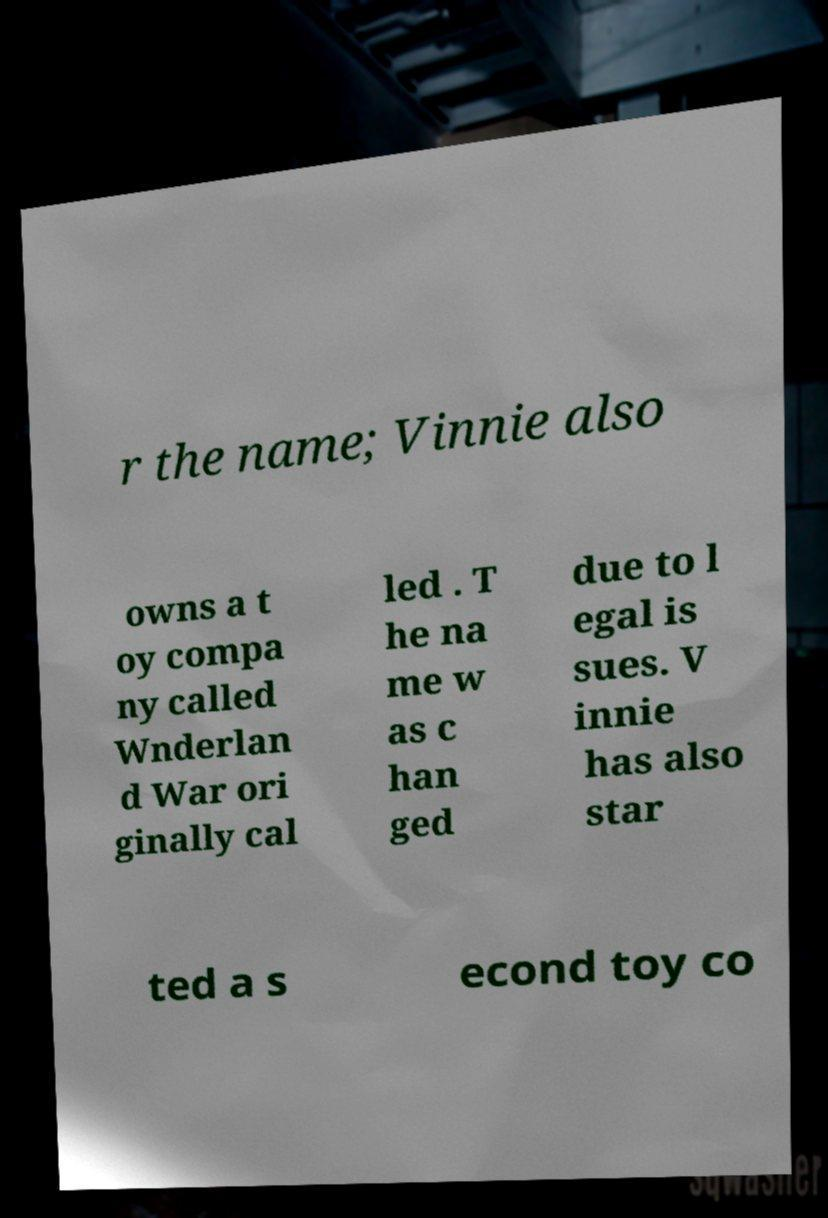Can you accurately transcribe the text from the provided image for me? r the name; Vinnie also owns a t oy compa ny called Wnderlan d War ori ginally cal led . T he na me w as c han ged due to l egal is sues. V innie has also star ted a s econd toy co 